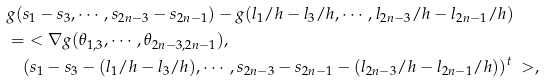<formula> <loc_0><loc_0><loc_500><loc_500>& g ( s _ { 1 } - s _ { 3 } , \cdots , s _ { 2 n - 3 } - s _ { 2 n - 1 } ) - g ( l _ { 1 } / h - l _ { 3 } / h , \cdots , l _ { 2 n - 3 } / h - l _ { 2 n - 1 } / h ) \\ & = \ < \nabla g ( \theta _ { 1 , 3 } , \cdots , \theta _ { 2 n - 3 , 2 n - 1 } ) , \\ & \quad ( s _ { 1 } - s _ { 3 } - ( l _ { 1 } / h - l _ { 3 } / h ) , \cdots , s _ { 2 n - 3 } - s _ { 2 n - 1 } - ( l _ { 2 n - 3 } / h - l _ { 2 n - 1 } / h ) ) ^ { t } \ > ,</formula> 